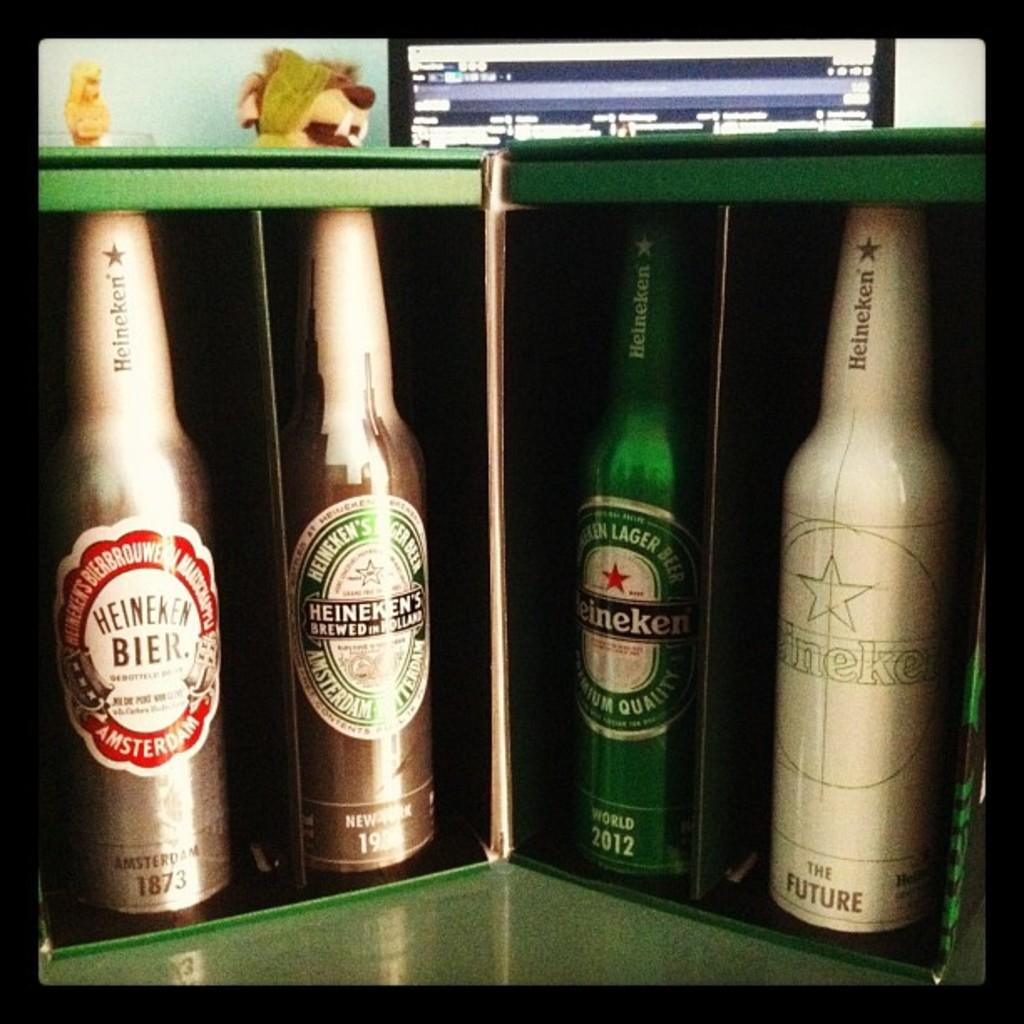<image>
Share a concise interpretation of the image provided. Four different bottles of Heineken beer are in a display. 